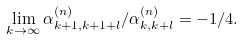<formula> <loc_0><loc_0><loc_500><loc_500>\lim _ { k \rightarrow \infty } \alpha _ { k + 1 , k + 1 + l } ^ { ( n ) } / \alpha _ { k , k + l } ^ { ( n ) } = - 1 / 4 .</formula> 